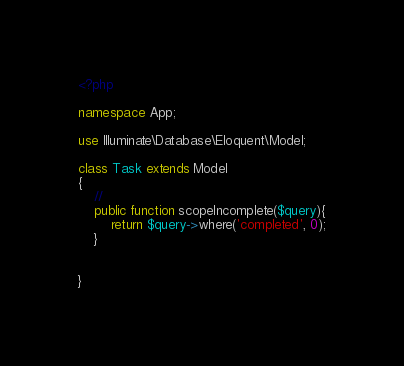<code> <loc_0><loc_0><loc_500><loc_500><_PHP_><?php

namespace App;

use Illuminate\Database\Eloquent\Model;

class Task extends Model
{
    //
    public function scopeIncomplete($query){
    	return $query->where('completed', 0);
    }

    
}
</code> 